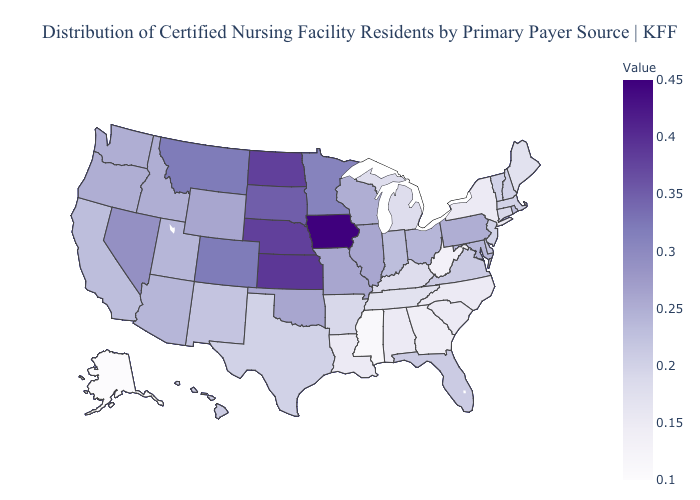Among the states that border Minnesota , does Wisconsin have the lowest value?
Give a very brief answer. Yes. Does Utah have the highest value in the USA?
Be succinct. No. Among the states that border Georgia , does Tennessee have the highest value?
Give a very brief answer. No. Which states have the lowest value in the USA?
Answer briefly. Alaska. Among the states that border Colorado , does Arizona have the lowest value?
Short answer required. No. Does Vermont have a higher value than West Virginia?
Quick response, please. Yes. Which states have the highest value in the USA?
Quick response, please. Iowa. 